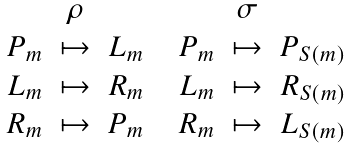Convert formula to latex. <formula><loc_0><loc_0><loc_500><loc_500>\begin{array} { c c c c c c c } & \rho & & & & \sigma & \\ P _ { m } & \mapsto & L _ { m } & & P _ { m } & \mapsto & P _ { S ( m ) } \\ L _ { m } & \mapsto & R _ { m } & & L _ { m } & \mapsto & R _ { S ( m ) } \\ R _ { m } & \mapsto & P _ { m } & & R _ { m } & \mapsto & L _ { S ( m ) } \end{array}</formula> 